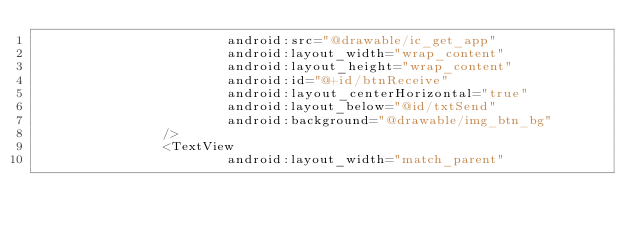<code> <loc_0><loc_0><loc_500><loc_500><_XML_>                        android:src="@drawable/ic_get_app"
                        android:layout_width="wrap_content"
                        android:layout_height="wrap_content"
                        android:id="@+id/btnReceive"
                        android:layout_centerHorizontal="true"
                        android:layout_below="@id/txtSend"
                        android:background="@drawable/img_btn_bg"
                />
                <TextView
                        android:layout_width="match_parent"</code> 